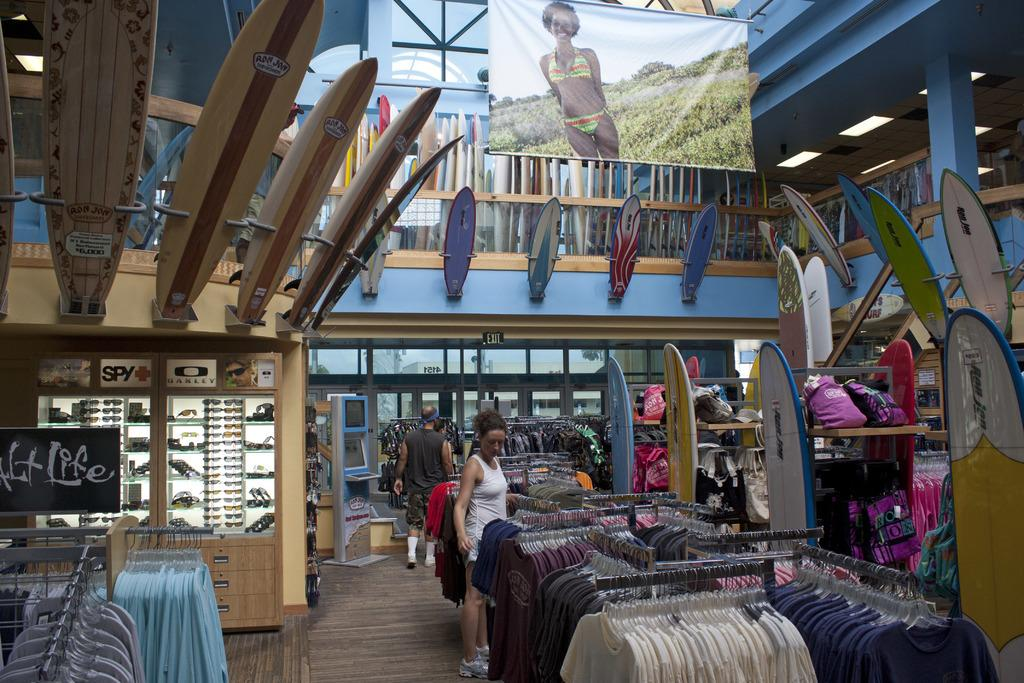What type of sports equipment can be seen in the image? There are surfboards in the image. What else can be seen in the image besides the surfboards? There are clothes, racks, banners, lights, a pillar, goggles, and persons standing on the floor in the image. What might be used for displaying or organizing items in the image? The racks in the image can be used for displaying or organizing items. What might be used for illumination in the image? The lights in the image can be used for illumination. Can you see any fairies flying around the surfboards in the image? There are no fairies present in the image. What type of paste is being used to copy the surfboards in the image? There is no paste or copying activity depicted in the image; it simply shows surfboards and other items. 